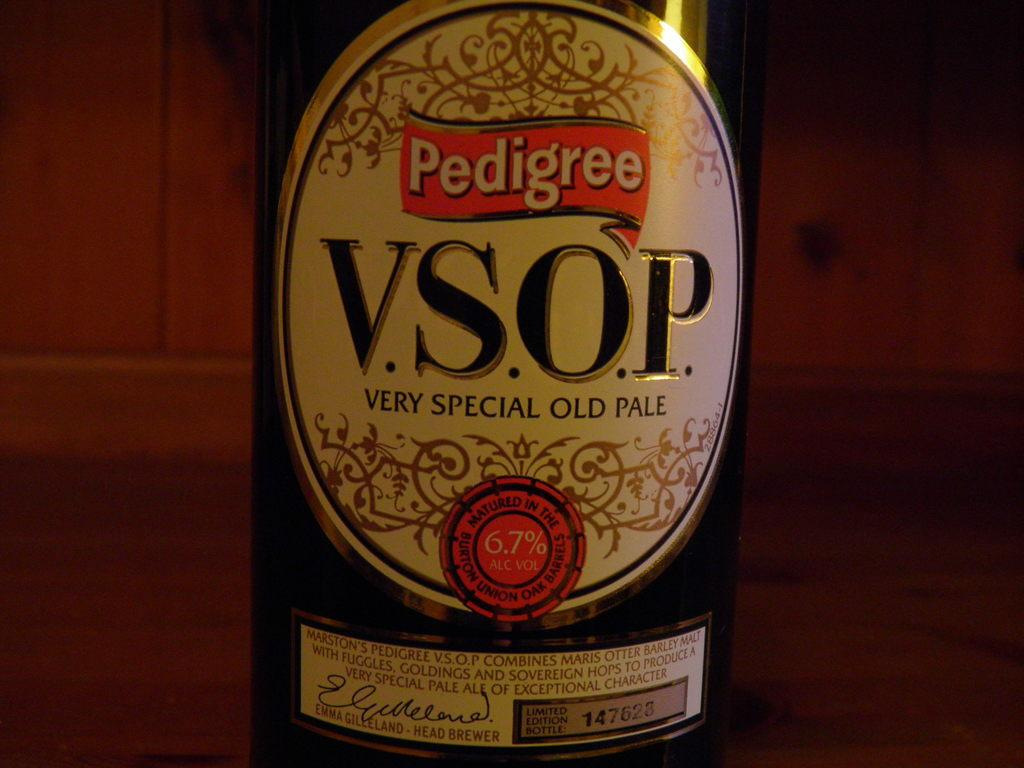<image>
Summarize the visual content of the image. The label on a bottle of Pedigree Very Special Old Pale declares 6.7% alc vol. 